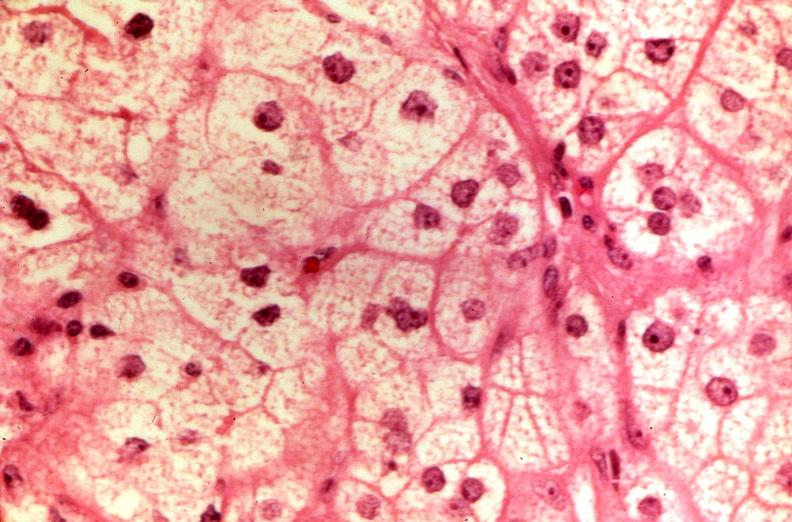what is present?
Answer the question using a single word or phrase. Endocrine 